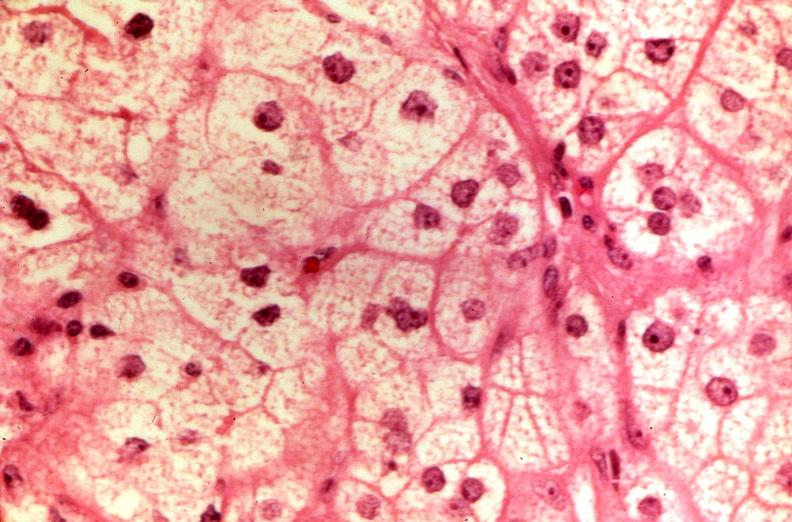what is present?
Answer the question using a single word or phrase. Endocrine 